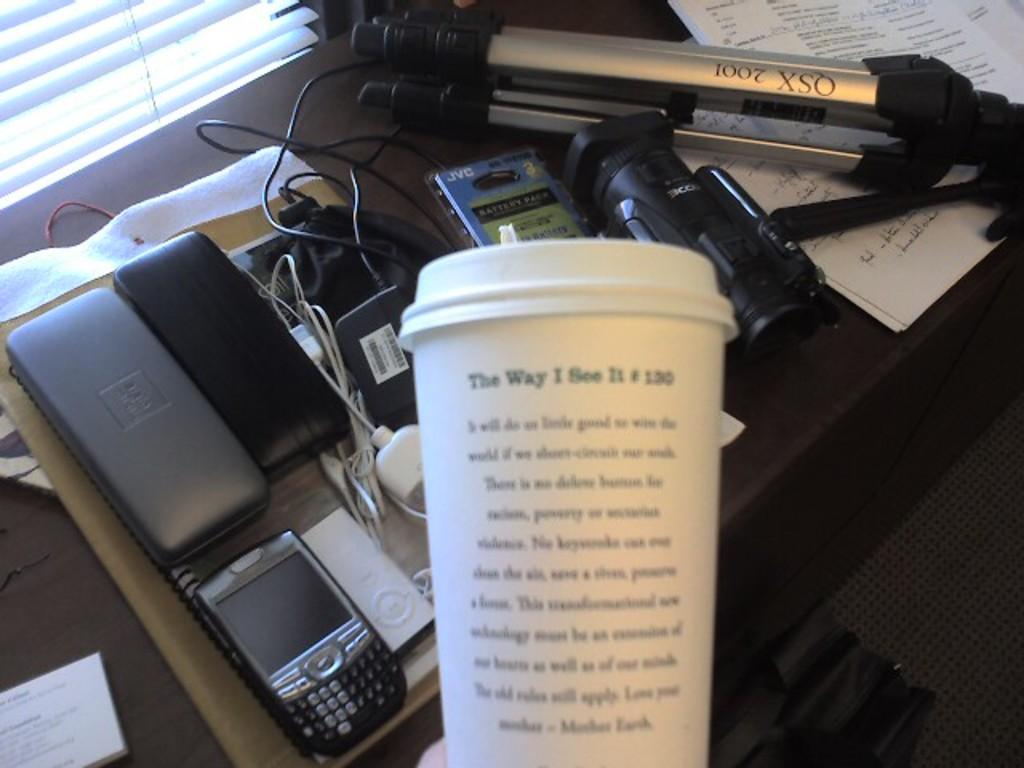What is the cup telling us?
Make the answer very short. The way i see it. What number is on the cup?
Your answer should be compact. 130. 